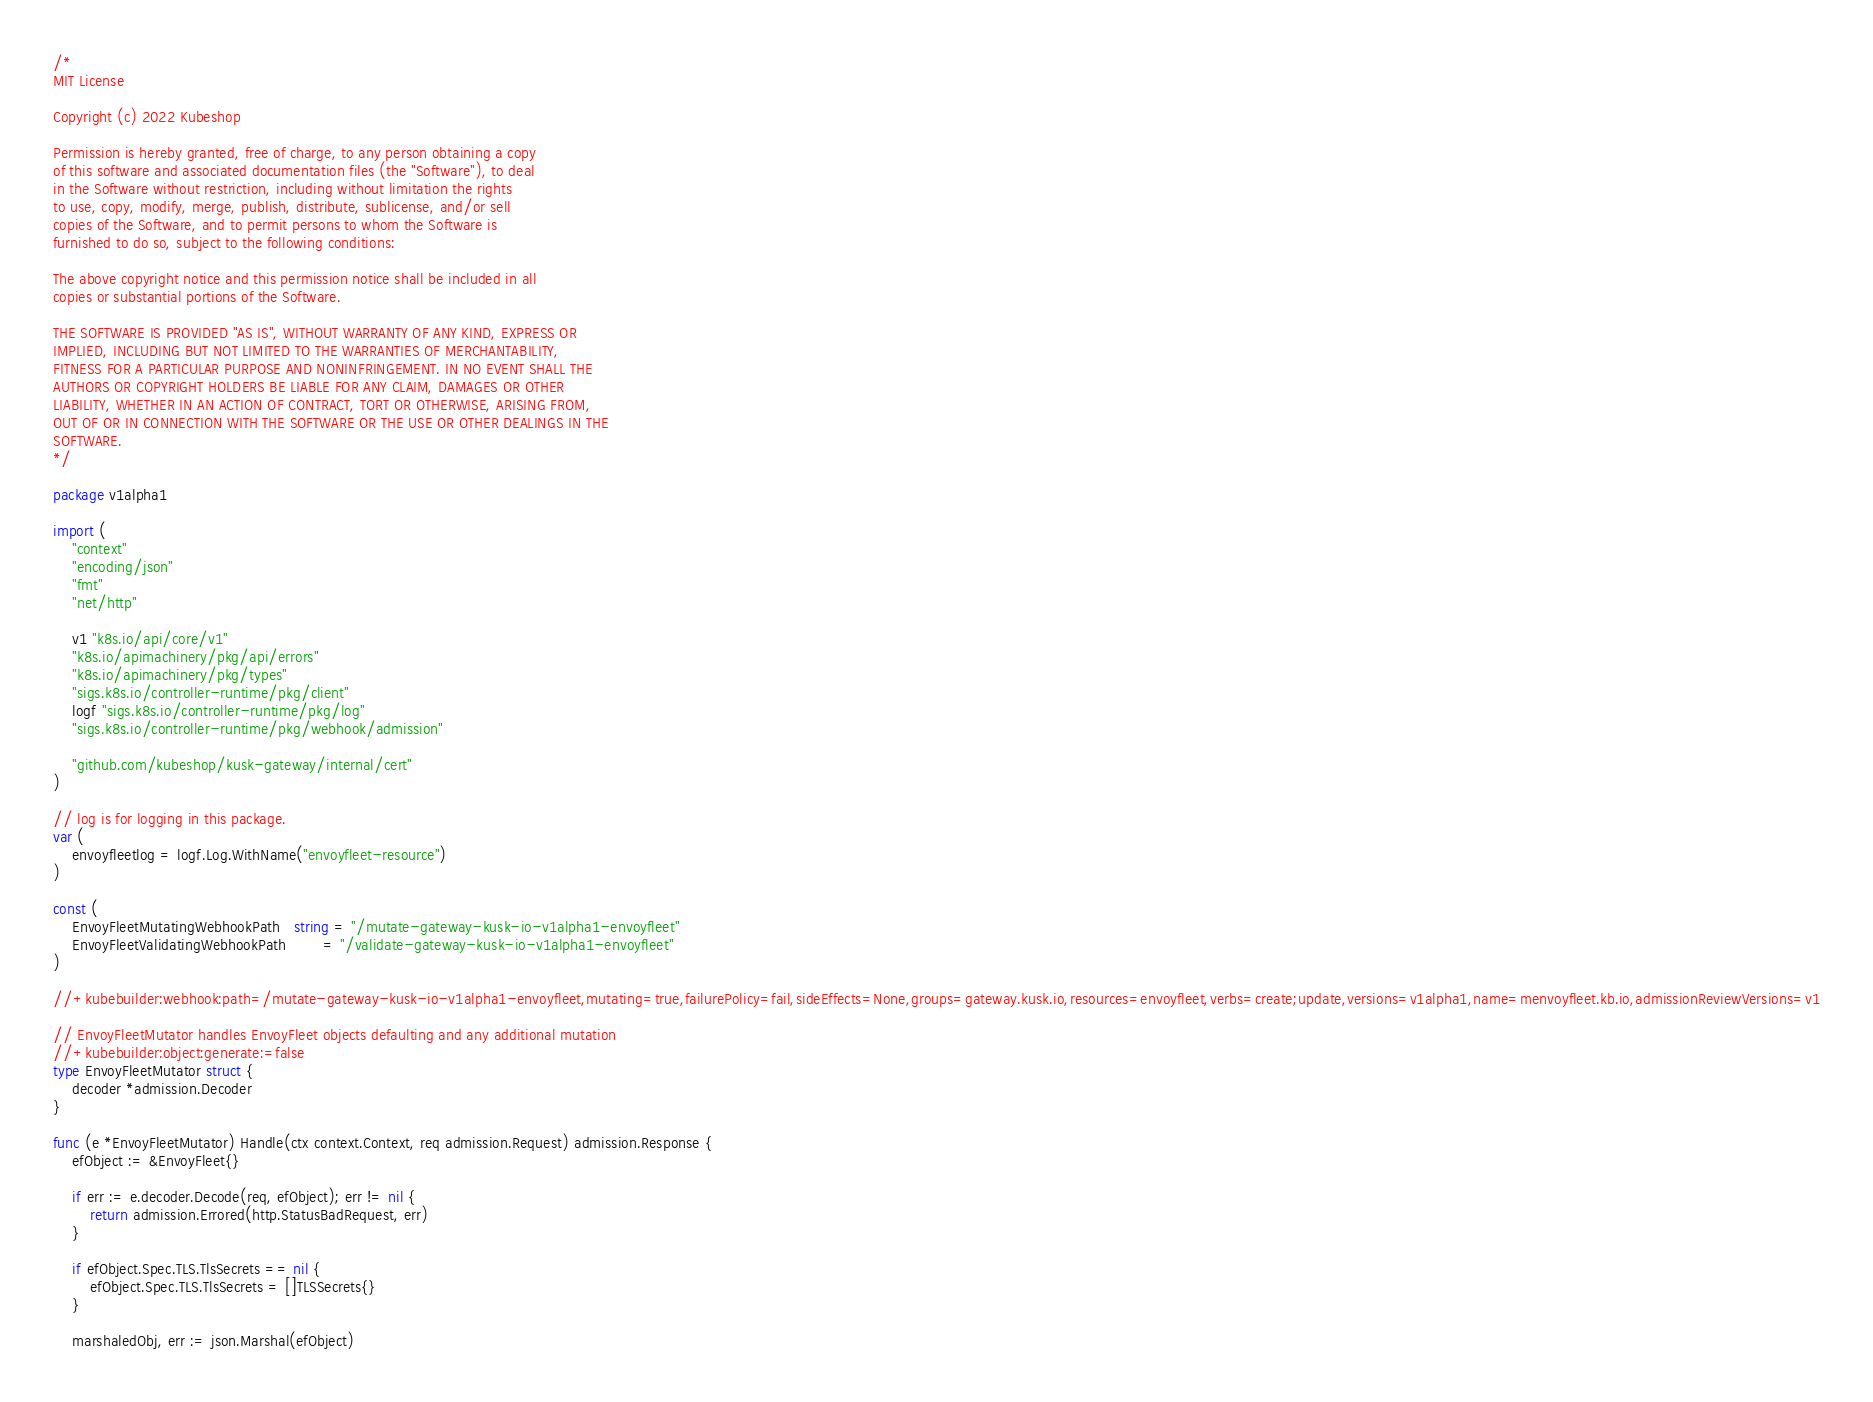<code> <loc_0><loc_0><loc_500><loc_500><_Go_>/*
MIT License

Copyright (c) 2022 Kubeshop

Permission is hereby granted, free of charge, to any person obtaining a copy
of this software and associated documentation files (the "Software"), to deal
in the Software without restriction, including without limitation the rights
to use, copy, modify, merge, publish, distribute, sublicense, and/or sell
copies of the Software, and to permit persons to whom the Software is
furnished to do so, subject to the following conditions:

The above copyright notice and this permission notice shall be included in all
copies or substantial portions of the Software.

THE SOFTWARE IS PROVIDED "AS IS", WITHOUT WARRANTY OF ANY KIND, EXPRESS OR
IMPLIED, INCLUDING BUT NOT LIMITED TO THE WARRANTIES OF MERCHANTABILITY,
FITNESS FOR A PARTICULAR PURPOSE AND NONINFRINGEMENT. IN NO EVENT SHALL THE
AUTHORS OR COPYRIGHT HOLDERS BE LIABLE FOR ANY CLAIM, DAMAGES OR OTHER
LIABILITY, WHETHER IN AN ACTION OF CONTRACT, TORT OR OTHERWISE, ARISING FROM,
OUT OF OR IN CONNECTION WITH THE SOFTWARE OR THE USE OR OTHER DEALINGS IN THE
SOFTWARE.
*/

package v1alpha1

import (
	"context"
	"encoding/json"
	"fmt"
	"net/http"

	v1 "k8s.io/api/core/v1"
	"k8s.io/apimachinery/pkg/api/errors"
	"k8s.io/apimachinery/pkg/types"
	"sigs.k8s.io/controller-runtime/pkg/client"
	logf "sigs.k8s.io/controller-runtime/pkg/log"
	"sigs.k8s.io/controller-runtime/pkg/webhook/admission"

	"github.com/kubeshop/kusk-gateway/internal/cert"
)

// log is for logging in this package.
var (
	envoyfleetlog = logf.Log.WithName("envoyfleet-resource")
)

const (
	EnvoyFleetMutatingWebhookPath   string = "/mutate-gateway-kusk-io-v1alpha1-envoyfleet"
	EnvoyFleetValidatingWebhookPath        = "/validate-gateway-kusk-io-v1alpha1-envoyfleet"
)

//+kubebuilder:webhook:path=/mutate-gateway-kusk-io-v1alpha1-envoyfleet,mutating=true,failurePolicy=fail,sideEffects=None,groups=gateway.kusk.io,resources=envoyfleet,verbs=create;update,versions=v1alpha1,name=menvoyfleet.kb.io,admissionReviewVersions=v1

// EnvoyFleetMutator handles EnvoyFleet objects defaulting and any additional mutation
//+kubebuilder:object:generate:=false
type EnvoyFleetMutator struct {
	decoder *admission.Decoder
}

func (e *EnvoyFleetMutator) Handle(ctx context.Context, req admission.Request) admission.Response {
	efObject := &EnvoyFleet{}

	if err := e.decoder.Decode(req, efObject); err != nil {
		return admission.Errored(http.StatusBadRequest, err)
	}

	if efObject.Spec.TLS.TlsSecrets == nil {
		efObject.Spec.TLS.TlsSecrets = []TLSSecrets{}
	}

	marshaledObj, err := json.Marshal(efObject)</code> 